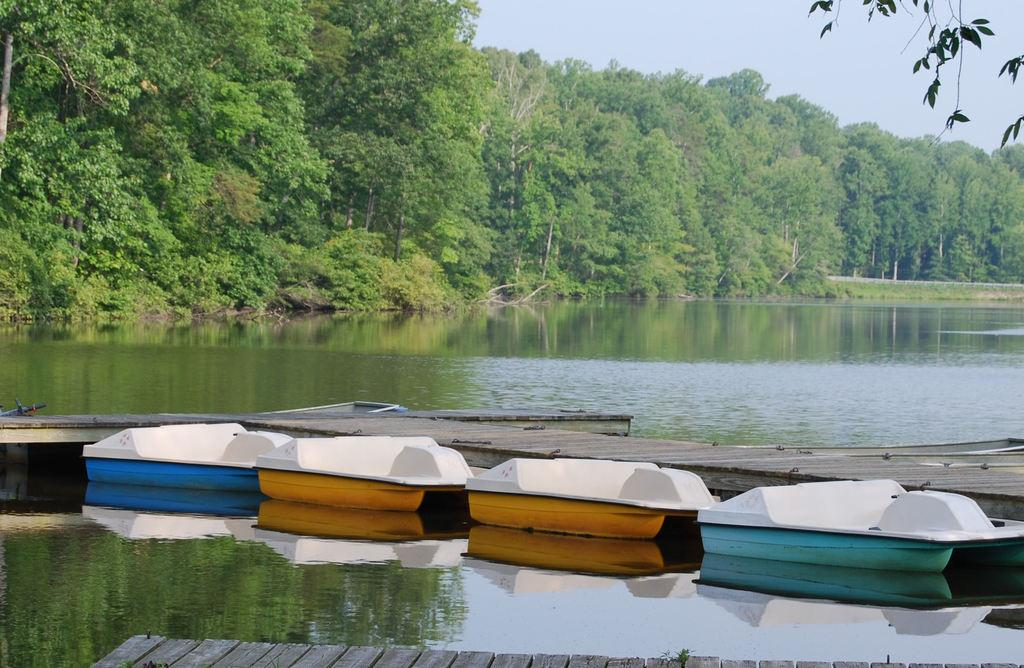What type of paths can be seen in the image? There are wooden paths in the image. What is floating on the water in the image? There are boats in the image. What is the water in the image situated on? The water is visible in the image. What type of vegetation is present in the image? There are trees in the image. What part of the natural environment is visible in the image? The sky is visible in the image. What type of fruit is hanging from the trees in the image? There is no fruit visible in the image; only trees are present. What type of cushion is used to support the boats in the image? There are no cushions present in the image; the boats are floating on the water. 